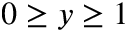<formula> <loc_0><loc_0><loc_500><loc_500>0 \geq y \geq 1</formula> 